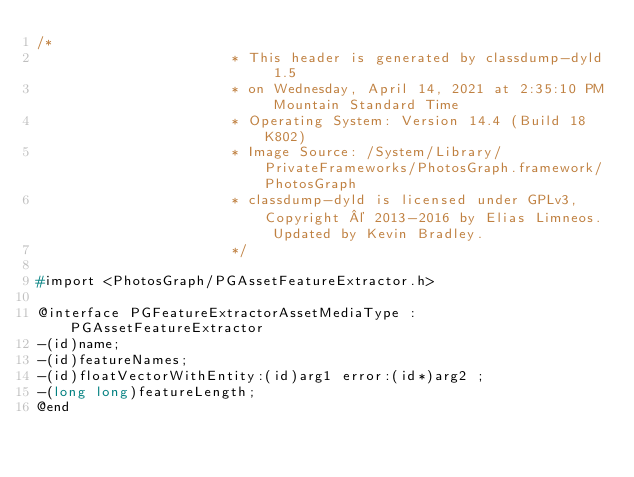Convert code to text. <code><loc_0><loc_0><loc_500><loc_500><_C_>/*
                       * This header is generated by classdump-dyld 1.5
                       * on Wednesday, April 14, 2021 at 2:35:10 PM Mountain Standard Time
                       * Operating System: Version 14.4 (Build 18K802)
                       * Image Source: /System/Library/PrivateFrameworks/PhotosGraph.framework/PhotosGraph
                       * classdump-dyld is licensed under GPLv3, Copyright © 2013-2016 by Elias Limneos. Updated by Kevin Bradley.
                       */

#import <PhotosGraph/PGAssetFeatureExtractor.h>

@interface PGFeatureExtractorAssetMediaType : PGAssetFeatureExtractor
-(id)name;
-(id)featureNames;
-(id)floatVectorWithEntity:(id)arg1 error:(id*)arg2 ;
-(long long)featureLength;
@end

</code> 